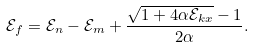Convert formula to latex. <formula><loc_0><loc_0><loc_500><loc_500>\mathcal { E } _ { f } = \mathcal { E } _ { n } - \mathcal { E } _ { m } + \frac { \sqrt { 1 + 4 \alpha \mathcal { E } _ { k x } } - 1 } { 2 \alpha } .</formula> 